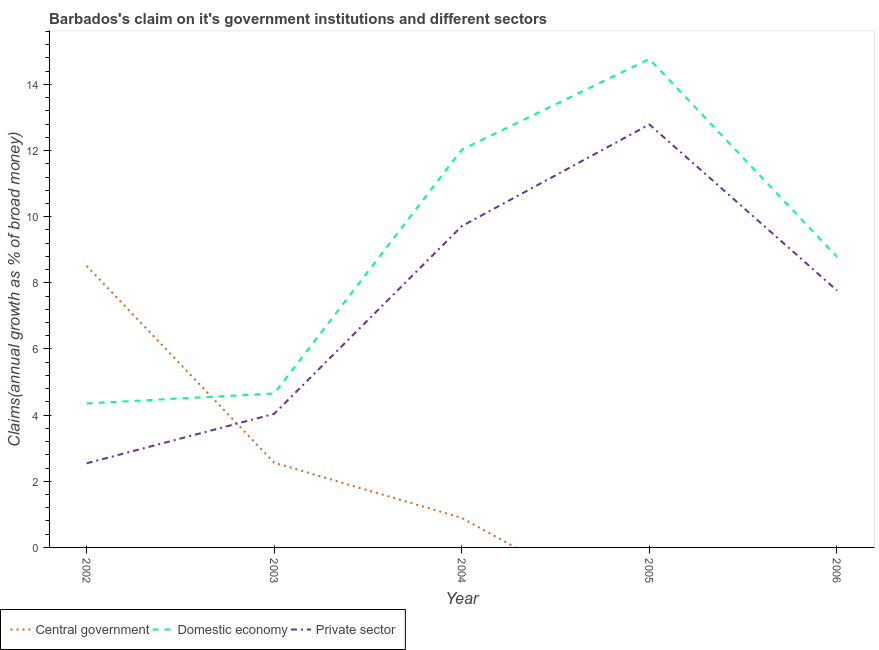How many different coloured lines are there?
Keep it short and to the point. 3. What is the percentage of claim on the private sector in 2004?
Offer a terse response. 9.72. Across all years, what is the maximum percentage of claim on the central government?
Your answer should be very brief. 8.51. What is the total percentage of claim on the private sector in the graph?
Offer a very short reply. 36.86. What is the difference between the percentage of claim on the private sector in 2005 and that in 2006?
Give a very brief answer. 5.02. What is the difference between the percentage of claim on the domestic economy in 2005 and the percentage of claim on the private sector in 2002?
Give a very brief answer. 12.23. What is the average percentage of claim on the central government per year?
Your answer should be very brief. 2.39. In the year 2006, what is the difference between the percentage of claim on the domestic economy and percentage of claim on the private sector?
Your response must be concise. 1.02. In how many years, is the percentage of claim on the central government greater than 1.2000000000000002 %?
Give a very brief answer. 2. What is the ratio of the percentage of claim on the central government in 2002 to that in 2003?
Make the answer very short. 3.33. Is the percentage of claim on the domestic economy in 2003 less than that in 2004?
Your answer should be compact. Yes. What is the difference between the highest and the second highest percentage of claim on the private sector?
Your answer should be very brief. 3.07. What is the difference between the highest and the lowest percentage of claim on the domestic economy?
Ensure brevity in your answer.  10.42. In how many years, is the percentage of claim on the central government greater than the average percentage of claim on the central government taken over all years?
Offer a terse response. 2. Is it the case that in every year, the sum of the percentage of claim on the central government and percentage of claim on the domestic economy is greater than the percentage of claim on the private sector?
Your answer should be very brief. Yes. Does the percentage of claim on the central government monotonically increase over the years?
Provide a short and direct response. No. How many lines are there?
Your answer should be compact. 3. What is the difference between two consecutive major ticks on the Y-axis?
Your answer should be very brief. 2. Are the values on the major ticks of Y-axis written in scientific E-notation?
Offer a terse response. No. Does the graph contain any zero values?
Provide a succinct answer. Yes. What is the title of the graph?
Make the answer very short. Barbados's claim on it's government institutions and different sectors. Does "Other sectors" appear as one of the legend labels in the graph?
Ensure brevity in your answer.  No. What is the label or title of the Y-axis?
Ensure brevity in your answer.  Claims(annual growth as % of broad money). What is the Claims(annual growth as % of broad money) in Central government in 2002?
Your answer should be very brief. 8.51. What is the Claims(annual growth as % of broad money) of Domestic economy in 2002?
Give a very brief answer. 4.35. What is the Claims(annual growth as % of broad money) of Private sector in 2002?
Offer a terse response. 2.54. What is the Claims(annual growth as % of broad money) of Central government in 2003?
Offer a very short reply. 2.56. What is the Claims(annual growth as % of broad money) in Domestic economy in 2003?
Provide a short and direct response. 4.66. What is the Claims(annual growth as % of broad money) in Private sector in 2003?
Keep it short and to the point. 4.04. What is the Claims(annual growth as % of broad money) in Central government in 2004?
Provide a short and direct response. 0.89. What is the Claims(annual growth as % of broad money) of Domestic economy in 2004?
Give a very brief answer. 12.03. What is the Claims(annual growth as % of broad money) in Private sector in 2004?
Offer a terse response. 9.72. What is the Claims(annual growth as % of broad money) of Domestic economy in 2005?
Offer a very short reply. 14.77. What is the Claims(annual growth as % of broad money) in Private sector in 2005?
Offer a terse response. 12.79. What is the Claims(annual growth as % of broad money) of Central government in 2006?
Ensure brevity in your answer.  0. What is the Claims(annual growth as % of broad money) in Domestic economy in 2006?
Make the answer very short. 8.79. What is the Claims(annual growth as % of broad money) of Private sector in 2006?
Give a very brief answer. 7.77. Across all years, what is the maximum Claims(annual growth as % of broad money) in Central government?
Your answer should be compact. 8.51. Across all years, what is the maximum Claims(annual growth as % of broad money) in Domestic economy?
Provide a succinct answer. 14.77. Across all years, what is the maximum Claims(annual growth as % of broad money) in Private sector?
Offer a terse response. 12.79. Across all years, what is the minimum Claims(annual growth as % of broad money) in Domestic economy?
Your answer should be compact. 4.35. Across all years, what is the minimum Claims(annual growth as % of broad money) in Private sector?
Provide a short and direct response. 2.54. What is the total Claims(annual growth as % of broad money) of Central government in the graph?
Provide a short and direct response. 11.97. What is the total Claims(annual growth as % of broad money) of Domestic economy in the graph?
Your answer should be compact. 44.6. What is the total Claims(annual growth as % of broad money) in Private sector in the graph?
Your response must be concise. 36.86. What is the difference between the Claims(annual growth as % of broad money) of Central government in 2002 and that in 2003?
Ensure brevity in your answer.  5.95. What is the difference between the Claims(annual growth as % of broad money) in Domestic economy in 2002 and that in 2003?
Keep it short and to the point. -0.3. What is the difference between the Claims(annual growth as % of broad money) in Private sector in 2002 and that in 2003?
Provide a succinct answer. -1.5. What is the difference between the Claims(annual growth as % of broad money) in Central government in 2002 and that in 2004?
Provide a succinct answer. 7.62. What is the difference between the Claims(annual growth as % of broad money) in Domestic economy in 2002 and that in 2004?
Your answer should be compact. -7.68. What is the difference between the Claims(annual growth as % of broad money) in Private sector in 2002 and that in 2004?
Make the answer very short. -7.17. What is the difference between the Claims(annual growth as % of broad money) in Domestic economy in 2002 and that in 2005?
Keep it short and to the point. -10.42. What is the difference between the Claims(annual growth as % of broad money) of Private sector in 2002 and that in 2005?
Make the answer very short. -10.25. What is the difference between the Claims(annual growth as % of broad money) of Domestic economy in 2002 and that in 2006?
Ensure brevity in your answer.  -4.43. What is the difference between the Claims(annual growth as % of broad money) in Private sector in 2002 and that in 2006?
Ensure brevity in your answer.  -5.23. What is the difference between the Claims(annual growth as % of broad money) of Central government in 2003 and that in 2004?
Give a very brief answer. 1.67. What is the difference between the Claims(annual growth as % of broad money) in Domestic economy in 2003 and that in 2004?
Your response must be concise. -7.37. What is the difference between the Claims(annual growth as % of broad money) of Private sector in 2003 and that in 2004?
Give a very brief answer. -5.68. What is the difference between the Claims(annual growth as % of broad money) in Domestic economy in 2003 and that in 2005?
Keep it short and to the point. -10.12. What is the difference between the Claims(annual growth as % of broad money) in Private sector in 2003 and that in 2005?
Keep it short and to the point. -8.75. What is the difference between the Claims(annual growth as % of broad money) of Domestic economy in 2003 and that in 2006?
Your response must be concise. -4.13. What is the difference between the Claims(annual growth as % of broad money) of Private sector in 2003 and that in 2006?
Offer a very short reply. -3.73. What is the difference between the Claims(annual growth as % of broad money) in Domestic economy in 2004 and that in 2005?
Offer a very short reply. -2.74. What is the difference between the Claims(annual growth as % of broad money) in Private sector in 2004 and that in 2005?
Offer a very short reply. -3.07. What is the difference between the Claims(annual growth as % of broad money) of Domestic economy in 2004 and that in 2006?
Ensure brevity in your answer.  3.24. What is the difference between the Claims(annual growth as % of broad money) of Private sector in 2004 and that in 2006?
Provide a succinct answer. 1.95. What is the difference between the Claims(annual growth as % of broad money) of Domestic economy in 2005 and that in 2006?
Make the answer very short. 5.98. What is the difference between the Claims(annual growth as % of broad money) of Private sector in 2005 and that in 2006?
Make the answer very short. 5.02. What is the difference between the Claims(annual growth as % of broad money) in Central government in 2002 and the Claims(annual growth as % of broad money) in Domestic economy in 2003?
Offer a very short reply. 3.86. What is the difference between the Claims(annual growth as % of broad money) of Central government in 2002 and the Claims(annual growth as % of broad money) of Private sector in 2003?
Ensure brevity in your answer.  4.47. What is the difference between the Claims(annual growth as % of broad money) of Domestic economy in 2002 and the Claims(annual growth as % of broad money) of Private sector in 2003?
Offer a terse response. 0.31. What is the difference between the Claims(annual growth as % of broad money) of Central government in 2002 and the Claims(annual growth as % of broad money) of Domestic economy in 2004?
Offer a terse response. -3.52. What is the difference between the Claims(annual growth as % of broad money) of Central government in 2002 and the Claims(annual growth as % of broad money) of Private sector in 2004?
Your response must be concise. -1.2. What is the difference between the Claims(annual growth as % of broad money) in Domestic economy in 2002 and the Claims(annual growth as % of broad money) in Private sector in 2004?
Provide a succinct answer. -5.36. What is the difference between the Claims(annual growth as % of broad money) in Central government in 2002 and the Claims(annual growth as % of broad money) in Domestic economy in 2005?
Give a very brief answer. -6.26. What is the difference between the Claims(annual growth as % of broad money) in Central government in 2002 and the Claims(annual growth as % of broad money) in Private sector in 2005?
Your answer should be compact. -4.27. What is the difference between the Claims(annual growth as % of broad money) of Domestic economy in 2002 and the Claims(annual growth as % of broad money) of Private sector in 2005?
Your answer should be compact. -8.43. What is the difference between the Claims(annual growth as % of broad money) in Central government in 2002 and the Claims(annual growth as % of broad money) in Domestic economy in 2006?
Provide a short and direct response. -0.27. What is the difference between the Claims(annual growth as % of broad money) of Central government in 2002 and the Claims(annual growth as % of broad money) of Private sector in 2006?
Your answer should be compact. 0.75. What is the difference between the Claims(annual growth as % of broad money) in Domestic economy in 2002 and the Claims(annual growth as % of broad money) in Private sector in 2006?
Offer a terse response. -3.41. What is the difference between the Claims(annual growth as % of broad money) in Central government in 2003 and the Claims(annual growth as % of broad money) in Domestic economy in 2004?
Give a very brief answer. -9.47. What is the difference between the Claims(annual growth as % of broad money) in Central government in 2003 and the Claims(annual growth as % of broad money) in Private sector in 2004?
Your response must be concise. -7.16. What is the difference between the Claims(annual growth as % of broad money) of Domestic economy in 2003 and the Claims(annual growth as % of broad money) of Private sector in 2004?
Your answer should be very brief. -5.06. What is the difference between the Claims(annual growth as % of broad money) of Central government in 2003 and the Claims(annual growth as % of broad money) of Domestic economy in 2005?
Give a very brief answer. -12.21. What is the difference between the Claims(annual growth as % of broad money) in Central government in 2003 and the Claims(annual growth as % of broad money) in Private sector in 2005?
Keep it short and to the point. -10.23. What is the difference between the Claims(annual growth as % of broad money) in Domestic economy in 2003 and the Claims(annual growth as % of broad money) in Private sector in 2005?
Your response must be concise. -8.13. What is the difference between the Claims(annual growth as % of broad money) in Central government in 2003 and the Claims(annual growth as % of broad money) in Domestic economy in 2006?
Provide a short and direct response. -6.23. What is the difference between the Claims(annual growth as % of broad money) in Central government in 2003 and the Claims(annual growth as % of broad money) in Private sector in 2006?
Your answer should be very brief. -5.21. What is the difference between the Claims(annual growth as % of broad money) of Domestic economy in 2003 and the Claims(annual growth as % of broad money) of Private sector in 2006?
Make the answer very short. -3.11. What is the difference between the Claims(annual growth as % of broad money) of Central government in 2004 and the Claims(annual growth as % of broad money) of Domestic economy in 2005?
Offer a very short reply. -13.88. What is the difference between the Claims(annual growth as % of broad money) in Central government in 2004 and the Claims(annual growth as % of broad money) in Private sector in 2005?
Offer a terse response. -11.9. What is the difference between the Claims(annual growth as % of broad money) in Domestic economy in 2004 and the Claims(annual growth as % of broad money) in Private sector in 2005?
Offer a terse response. -0.76. What is the difference between the Claims(annual growth as % of broad money) of Central government in 2004 and the Claims(annual growth as % of broad money) of Domestic economy in 2006?
Provide a short and direct response. -7.9. What is the difference between the Claims(annual growth as % of broad money) in Central government in 2004 and the Claims(annual growth as % of broad money) in Private sector in 2006?
Give a very brief answer. -6.88. What is the difference between the Claims(annual growth as % of broad money) in Domestic economy in 2004 and the Claims(annual growth as % of broad money) in Private sector in 2006?
Offer a terse response. 4.26. What is the difference between the Claims(annual growth as % of broad money) in Domestic economy in 2005 and the Claims(annual growth as % of broad money) in Private sector in 2006?
Provide a short and direct response. 7. What is the average Claims(annual growth as % of broad money) in Central government per year?
Your answer should be compact. 2.39. What is the average Claims(annual growth as % of broad money) in Domestic economy per year?
Offer a terse response. 8.92. What is the average Claims(annual growth as % of broad money) of Private sector per year?
Your response must be concise. 7.37. In the year 2002, what is the difference between the Claims(annual growth as % of broad money) of Central government and Claims(annual growth as % of broad money) of Domestic economy?
Offer a very short reply. 4.16. In the year 2002, what is the difference between the Claims(annual growth as % of broad money) of Central government and Claims(annual growth as % of broad money) of Private sector?
Make the answer very short. 5.97. In the year 2002, what is the difference between the Claims(annual growth as % of broad money) in Domestic economy and Claims(annual growth as % of broad money) in Private sector?
Your response must be concise. 1.81. In the year 2003, what is the difference between the Claims(annual growth as % of broad money) of Central government and Claims(annual growth as % of broad money) of Domestic economy?
Provide a succinct answer. -2.1. In the year 2003, what is the difference between the Claims(annual growth as % of broad money) of Central government and Claims(annual growth as % of broad money) of Private sector?
Make the answer very short. -1.48. In the year 2003, what is the difference between the Claims(annual growth as % of broad money) of Domestic economy and Claims(annual growth as % of broad money) of Private sector?
Offer a very short reply. 0.62. In the year 2004, what is the difference between the Claims(annual growth as % of broad money) of Central government and Claims(annual growth as % of broad money) of Domestic economy?
Ensure brevity in your answer.  -11.14. In the year 2004, what is the difference between the Claims(annual growth as % of broad money) of Central government and Claims(annual growth as % of broad money) of Private sector?
Provide a succinct answer. -8.82. In the year 2004, what is the difference between the Claims(annual growth as % of broad money) in Domestic economy and Claims(annual growth as % of broad money) in Private sector?
Your response must be concise. 2.31. In the year 2005, what is the difference between the Claims(annual growth as % of broad money) of Domestic economy and Claims(annual growth as % of broad money) of Private sector?
Make the answer very short. 1.98. In the year 2006, what is the difference between the Claims(annual growth as % of broad money) in Domestic economy and Claims(annual growth as % of broad money) in Private sector?
Your response must be concise. 1.02. What is the ratio of the Claims(annual growth as % of broad money) of Central government in 2002 to that in 2003?
Ensure brevity in your answer.  3.33. What is the ratio of the Claims(annual growth as % of broad money) in Domestic economy in 2002 to that in 2003?
Give a very brief answer. 0.94. What is the ratio of the Claims(annual growth as % of broad money) in Private sector in 2002 to that in 2003?
Offer a very short reply. 0.63. What is the ratio of the Claims(annual growth as % of broad money) in Central government in 2002 to that in 2004?
Ensure brevity in your answer.  9.55. What is the ratio of the Claims(annual growth as % of broad money) in Domestic economy in 2002 to that in 2004?
Your answer should be compact. 0.36. What is the ratio of the Claims(annual growth as % of broad money) of Private sector in 2002 to that in 2004?
Keep it short and to the point. 0.26. What is the ratio of the Claims(annual growth as % of broad money) of Domestic economy in 2002 to that in 2005?
Provide a succinct answer. 0.29. What is the ratio of the Claims(annual growth as % of broad money) of Private sector in 2002 to that in 2005?
Ensure brevity in your answer.  0.2. What is the ratio of the Claims(annual growth as % of broad money) of Domestic economy in 2002 to that in 2006?
Your answer should be very brief. 0.5. What is the ratio of the Claims(annual growth as % of broad money) in Private sector in 2002 to that in 2006?
Your response must be concise. 0.33. What is the ratio of the Claims(annual growth as % of broad money) in Central government in 2003 to that in 2004?
Offer a very short reply. 2.87. What is the ratio of the Claims(annual growth as % of broad money) of Domestic economy in 2003 to that in 2004?
Make the answer very short. 0.39. What is the ratio of the Claims(annual growth as % of broad money) in Private sector in 2003 to that in 2004?
Give a very brief answer. 0.42. What is the ratio of the Claims(annual growth as % of broad money) in Domestic economy in 2003 to that in 2005?
Your answer should be very brief. 0.32. What is the ratio of the Claims(annual growth as % of broad money) of Private sector in 2003 to that in 2005?
Your answer should be compact. 0.32. What is the ratio of the Claims(annual growth as % of broad money) in Domestic economy in 2003 to that in 2006?
Your response must be concise. 0.53. What is the ratio of the Claims(annual growth as % of broad money) in Private sector in 2003 to that in 2006?
Ensure brevity in your answer.  0.52. What is the ratio of the Claims(annual growth as % of broad money) of Domestic economy in 2004 to that in 2005?
Ensure brevity in your answer.  0.81. What is the ratio of the Claims(annual growth as % of broad money) in Private sector in 2004 to that in 2005?
Offer a terse response. 0.76. What is the ratio of the Claims(annual growth as % of broad money) of Domestic economy in 2004 to that in 2006?
Give a very brief answer. 1.37. What is the ratio of the Claims(annual growth as % of broad money) in Private sector in 2004 to that in 2006?
Your answer should be very brief. 1.25. What is the ratio of the Claims(annual growth as % of broad money) in Domestic economy in 2005 to that in 2006?
Make the answer very short. 1.68. What is the ratio of the Claims(annual growth as % of broad money) of Private sector in 2005 to that in 2006?
Ensure brevity in your answer.  1.65. What is the difference between the highest and the second highest Claims(annual growth as % of broad money) of Central government?
Offer a terse response. 5.95. What is the difference between the highest and the second highest Claims(annual growth as % of broad money) in Domestic economy?
Offer a terse response. 2.74. What is the difference between the highest and the second highest Claims(annual growth as % of broad money) of Private sector?
Your answer should be compact. 3.07. What is the difference between the highest and the lowest Claims(annual growth as % of broad money) in Central government?
Keep it short and to the point. 8.51. What is the difference between the highest and the lowest Claims(annual growth as % of broad money) in Domestic economy?
Provide a short and direct response. 10.42. What is the difference between the highest and the lowest Claims(annual growth as % of broad money) of Private sector?
Give a very brief answer. 10.25. 